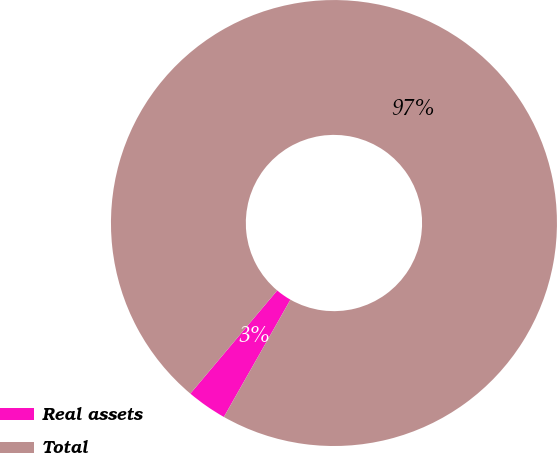Convert chart to OTSL. <chart><loc_0><loc_0><loc_500><loc_500><pie_chart><fcel>Real assets<fcel>Total<nl><fcel>2.92%<fcel>97.08%<nl></chart> 